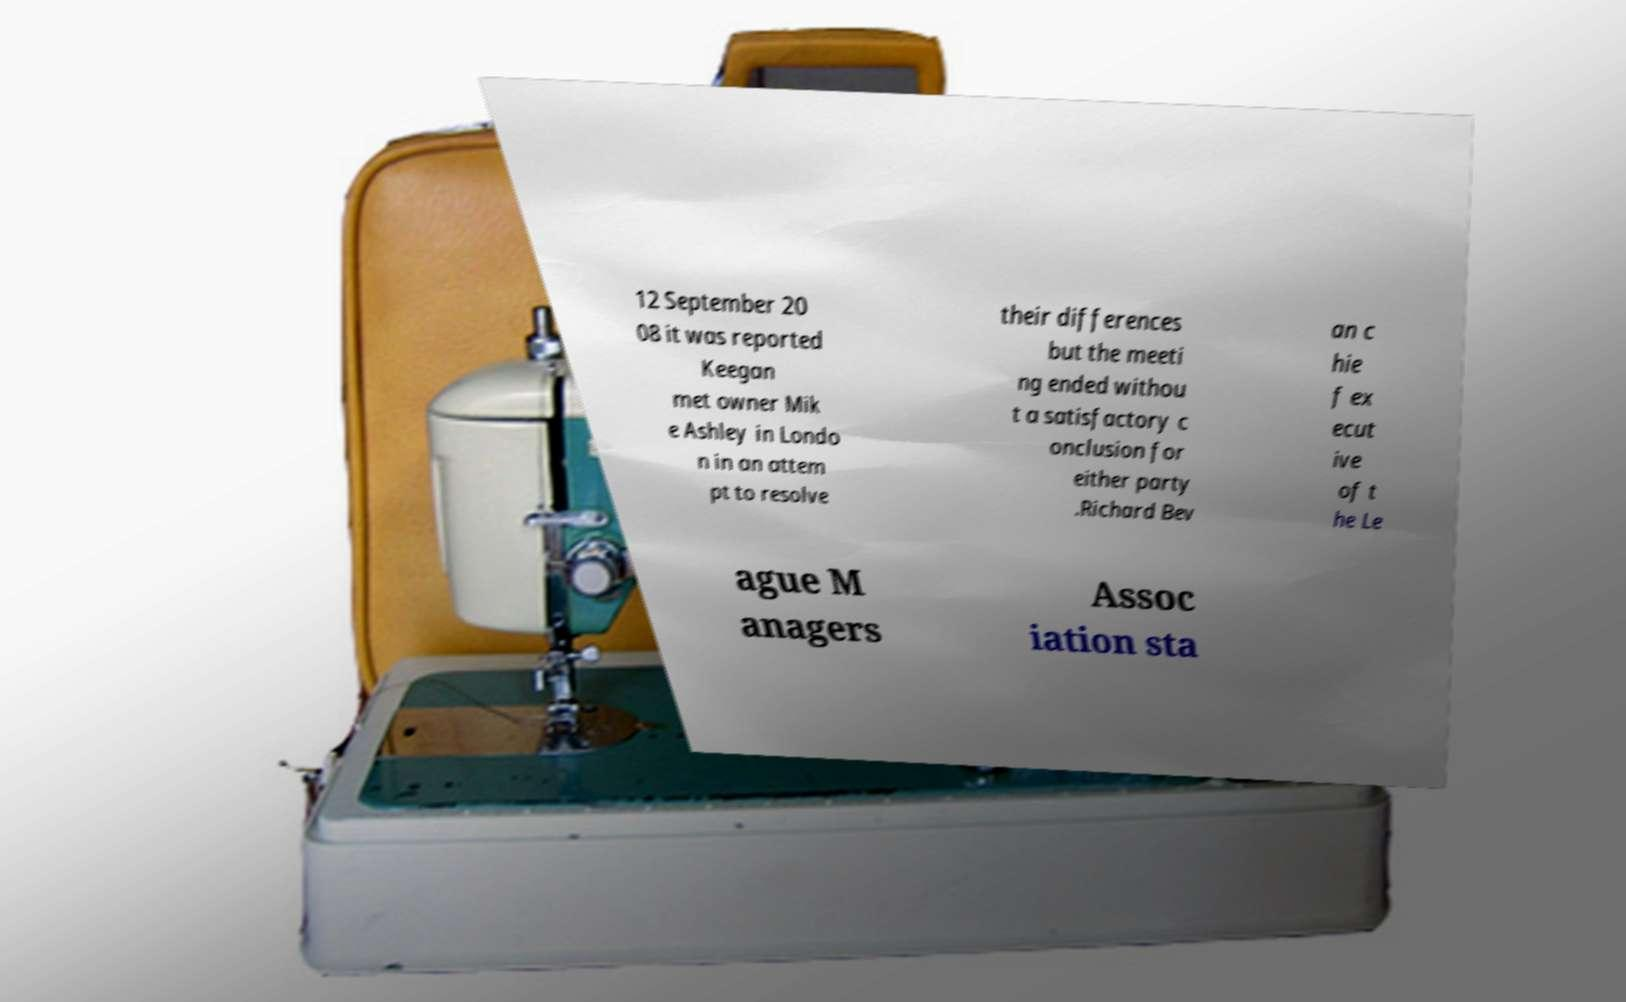There's text embedded in this image that I need extracted. Can you transcribe it verbatim? 12 September 20 08 it was reported Keegan met owner Mik e Ashley in Londo n in an attem pt to resolve their differences but the meeti ng ended withou t a satisfactory c onclusion for either party .Richard Bev an c hie f ex ecut ive of t he Le ague M anagers Assoc iation sta 